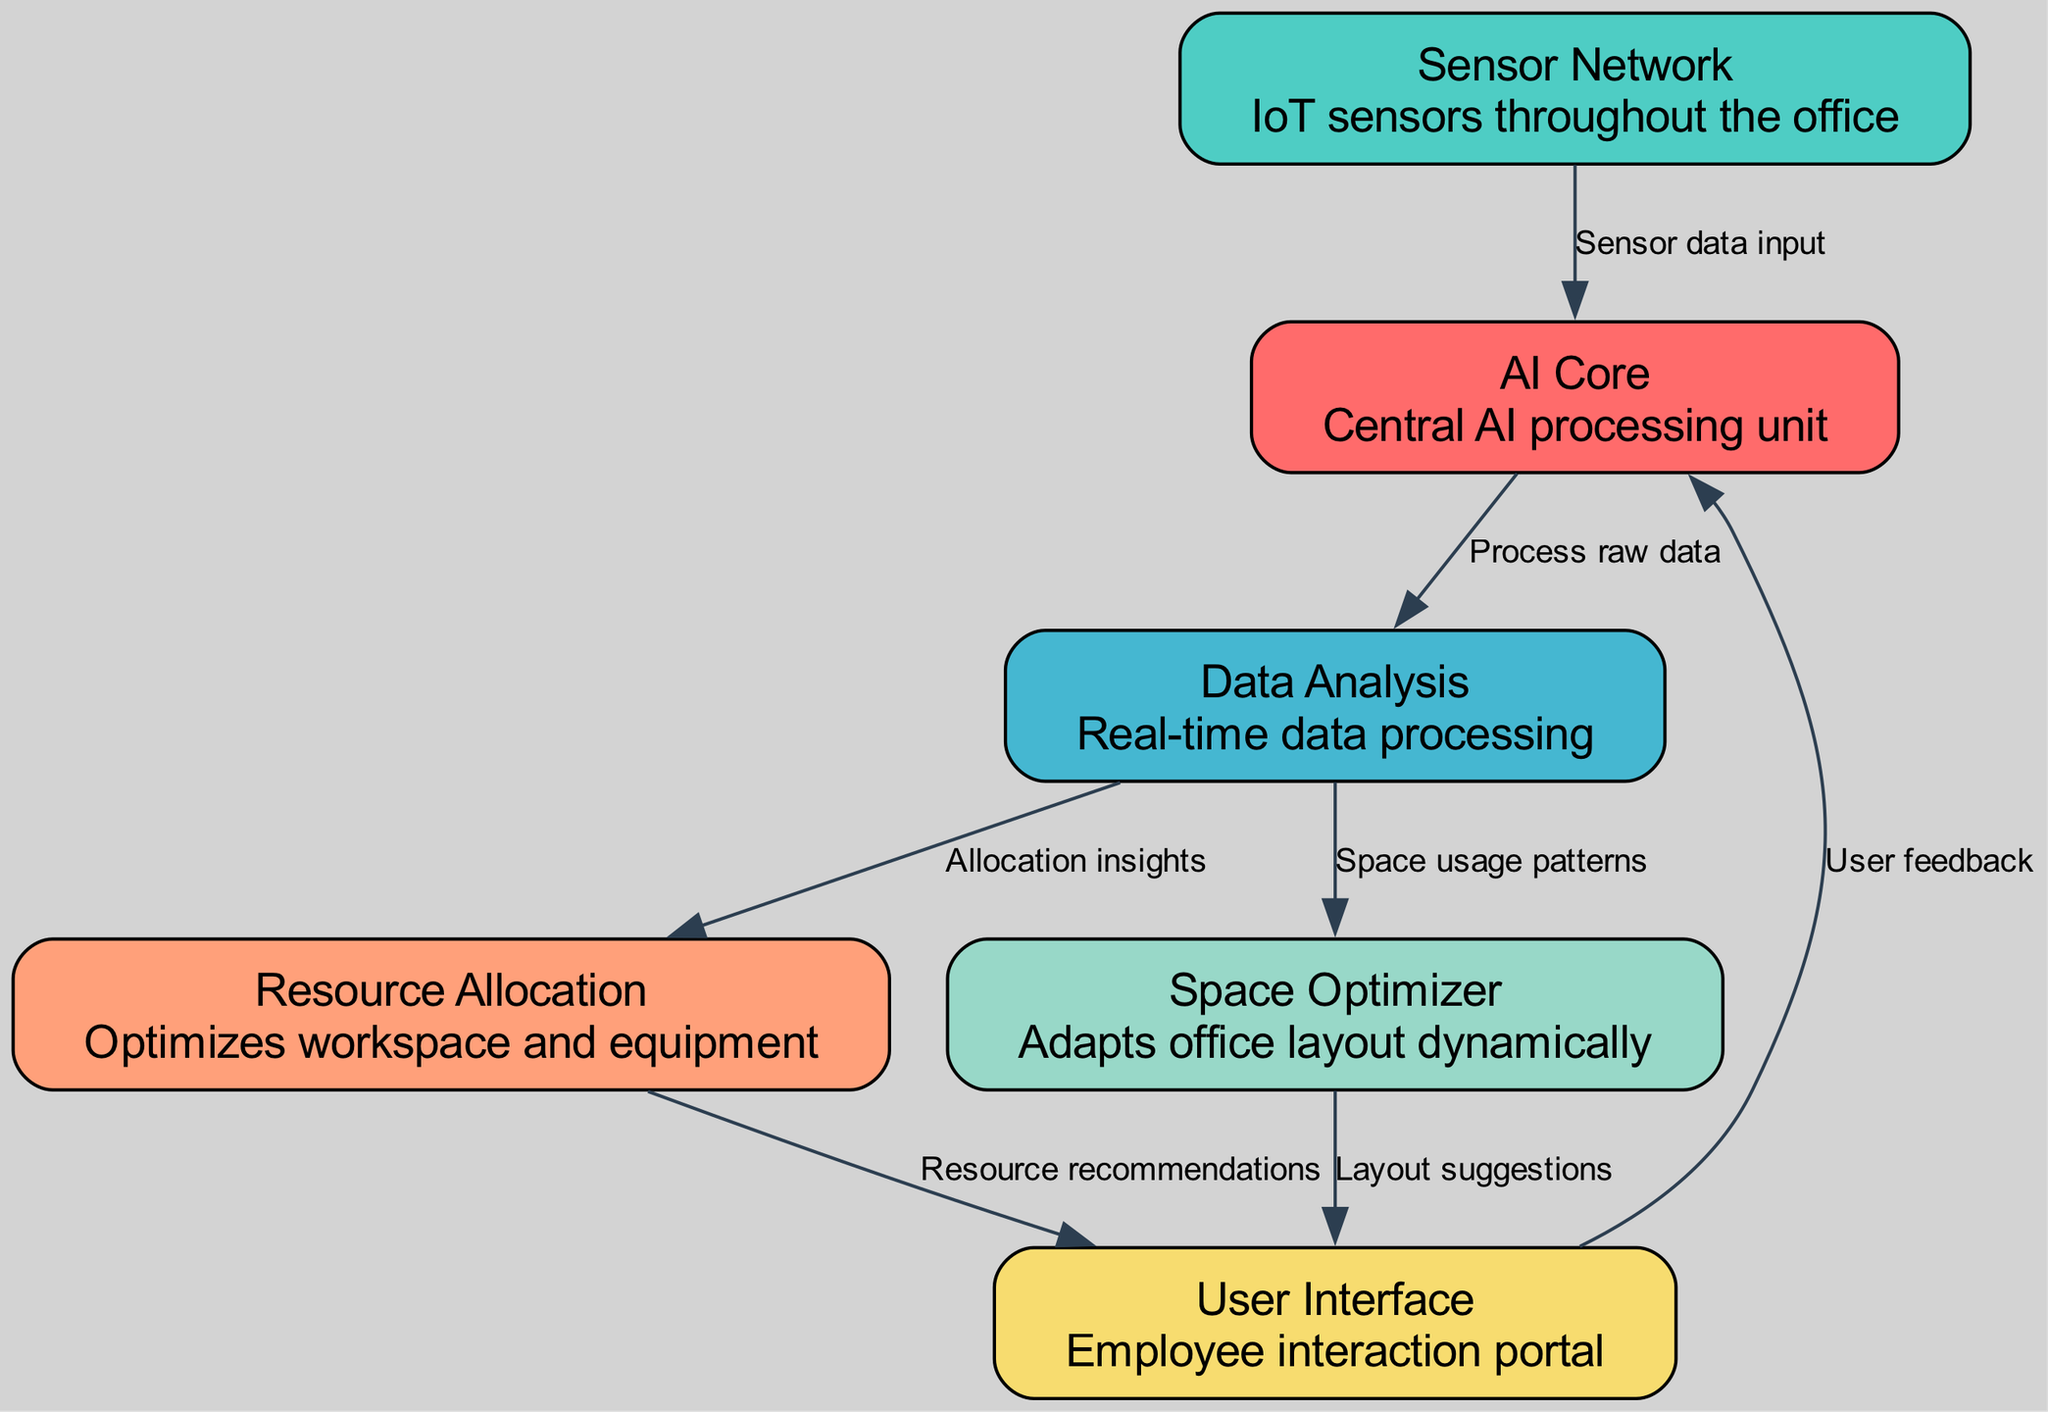What is the central processing unit of the system? The node labeled "AI Core" represents the central AI processing unit of the system, as directly shown in the diagram.
Answer: AI Core How many nodes are in the workflow diagram? The diagram contains six distinct nodes, as listed under the nodes section in the provided data.
Answer: 6 Which node receives input from the Sensor Network? According to the diagram's edge, the "AI Core" receives input from the "Sensor Network," indicating a direct relationship between these two nodes.
Answer: AI Core What type of data does the AI Core process? The AI Core is shown to process "raw data" as indicated by the label on the edge connecting the AI Core to the Data Analysis node.
Answer: Raw data What are the two outputs of the Data Analysis node? The Data Analysis node produces insights for "Resource Allocation" and "Space Optimizer," as seen in the diagram's outgoing edges.
Answer: Resource Allocation and Space Optimizer What feedback does the User Interface provide back to the AI Core? The User Interface sends "User feedback" to the AI Core, which is specified by the edge connecting these two nodes in the diagram.
Answer: User feedback Which node directly contributes to layout suggestions? The "Space Optimizer" is responsible for providing "Layout suggestions," as indicated by the edge leading from the Space Optimizer to the User Interface.
Answer: Space Optimizer What is the role of the Resource Allocation node? The Resource Allocation node specializes in optimizing workspace and equipment, as described in the node's description in the diagram.
Answer: Optimizes workspace and equipment How does the Sensor Network contribute to the AI Core? The Sensor Network supplies information through "Sensor data input," which is the specific edge that connects these two nodes in the workflow.
Answer: Sensor data input Which nodes are linked based on allocation insights? The "Data Analysis" node and "Resource Allocation" node are linked because the Data Analysis provides "Allocation insights" to the Resource Allocation node according to the diagram's edges.
Answer: Data Analysis and Resource Allocation 